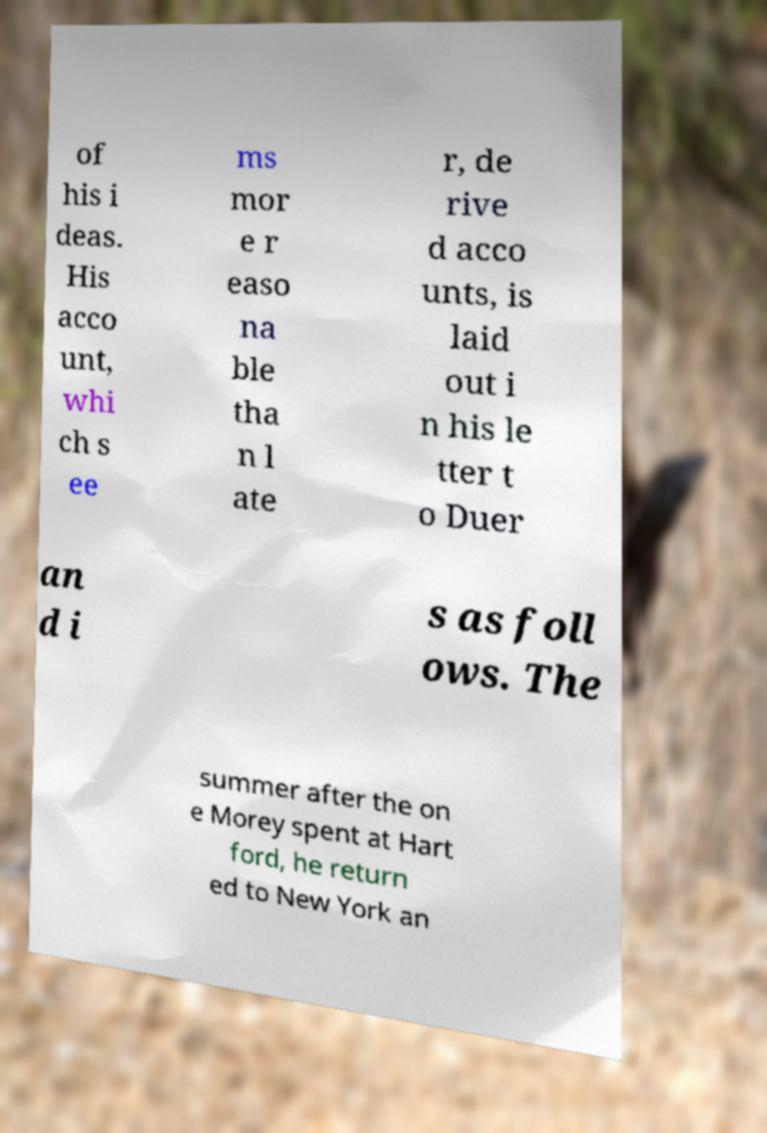I need the written content from this picture converted into text. Can you do that? of his i deas. His acco unt, whi ch s ee ms mor e r easo na ble tha n l ate r, de rive d acco unts, is laid out i n his le tter t o Duer an d i s as foll ows. The summer after the on e Morey spent at Hart ford, he return ed to New York an 